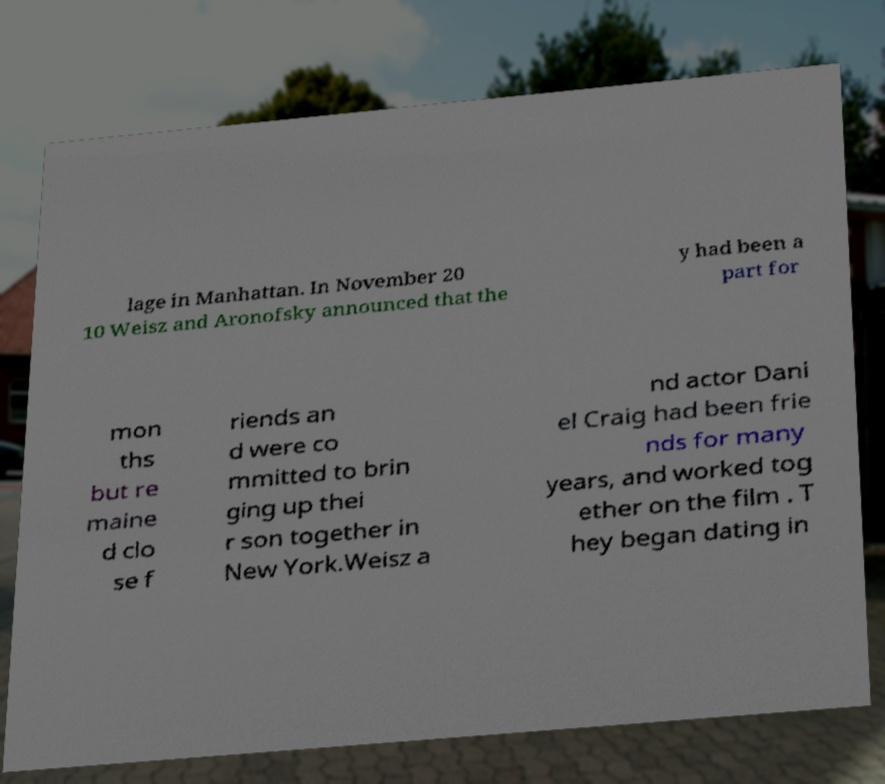Please read and relay the text visible in this image. What does it say? lage in Manhattan. In November 20 10 Weisz and Aronofsky announced that the y had been a part for mon ths but re maine d clo se f riends an d were co mmitted to brin ging up thei r son together in New York.Weisz a nd actor Dani el Craig had been frie nds for many years, and worked tog ether on the film . T hey began dating in 